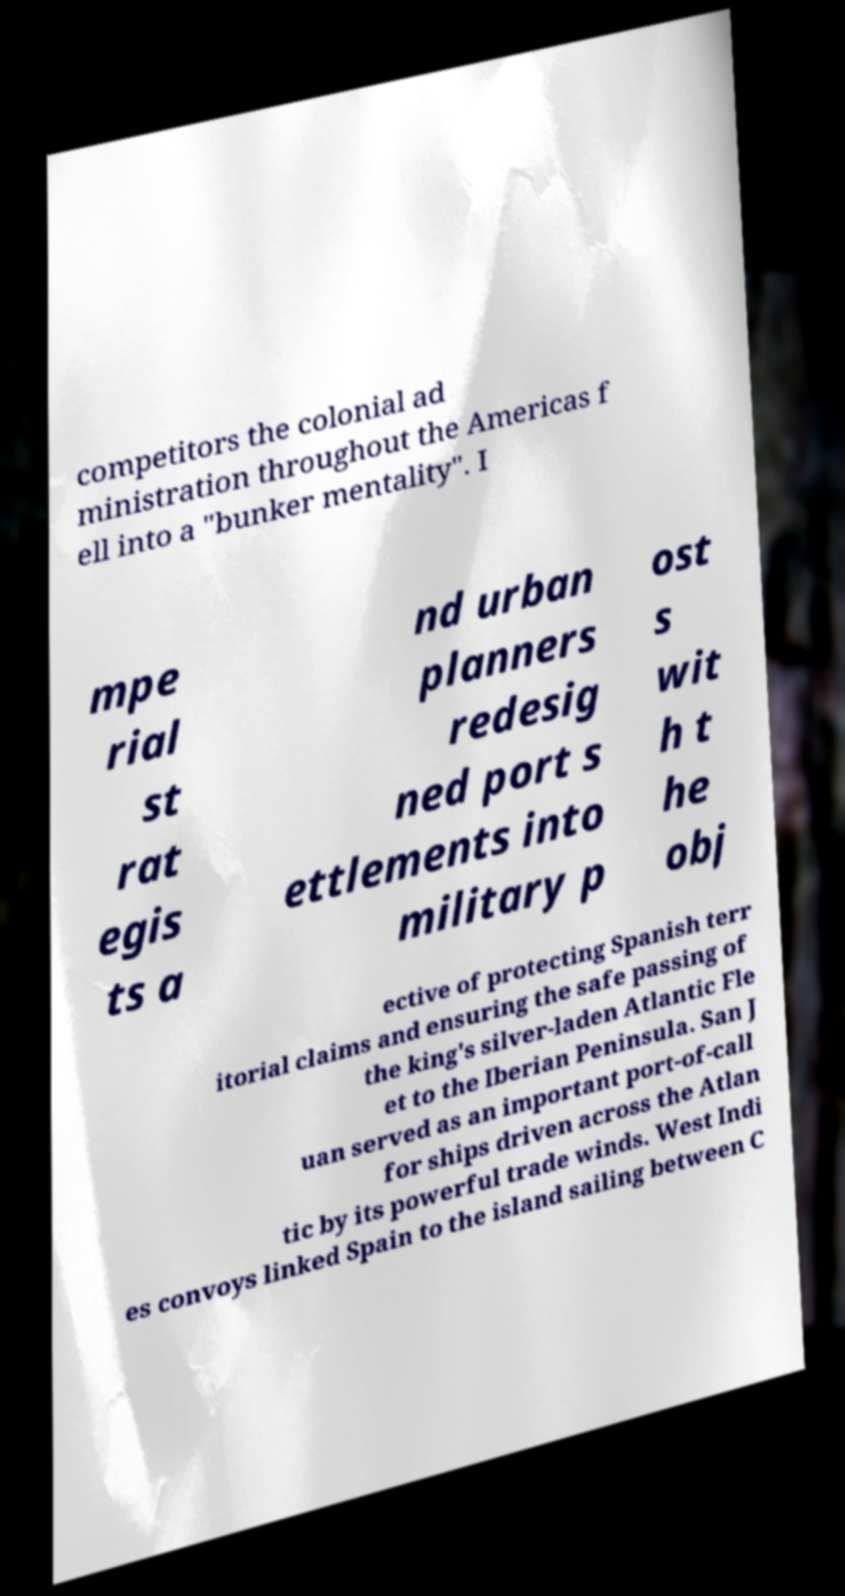Please read and relay the text visible in this image. What does it say? competitors the colonial ad ministration throughout the Americas f ell into a "bunker mentality". I mpe rial st rat egis ts a nd urban planners redesig ned port s ettlements into military p ost s wit h t he obj ective of protecting Spanish terr itorial claims and ensuring the safe passing of the king's silver-laden Atlantic Fle et to the Iberian Peninsula. San J uan served as an important port-of-call for ships driven across the Atlan tic by its powerful trade winds. West Indi es convoys linked Spain to the island sailing between C 